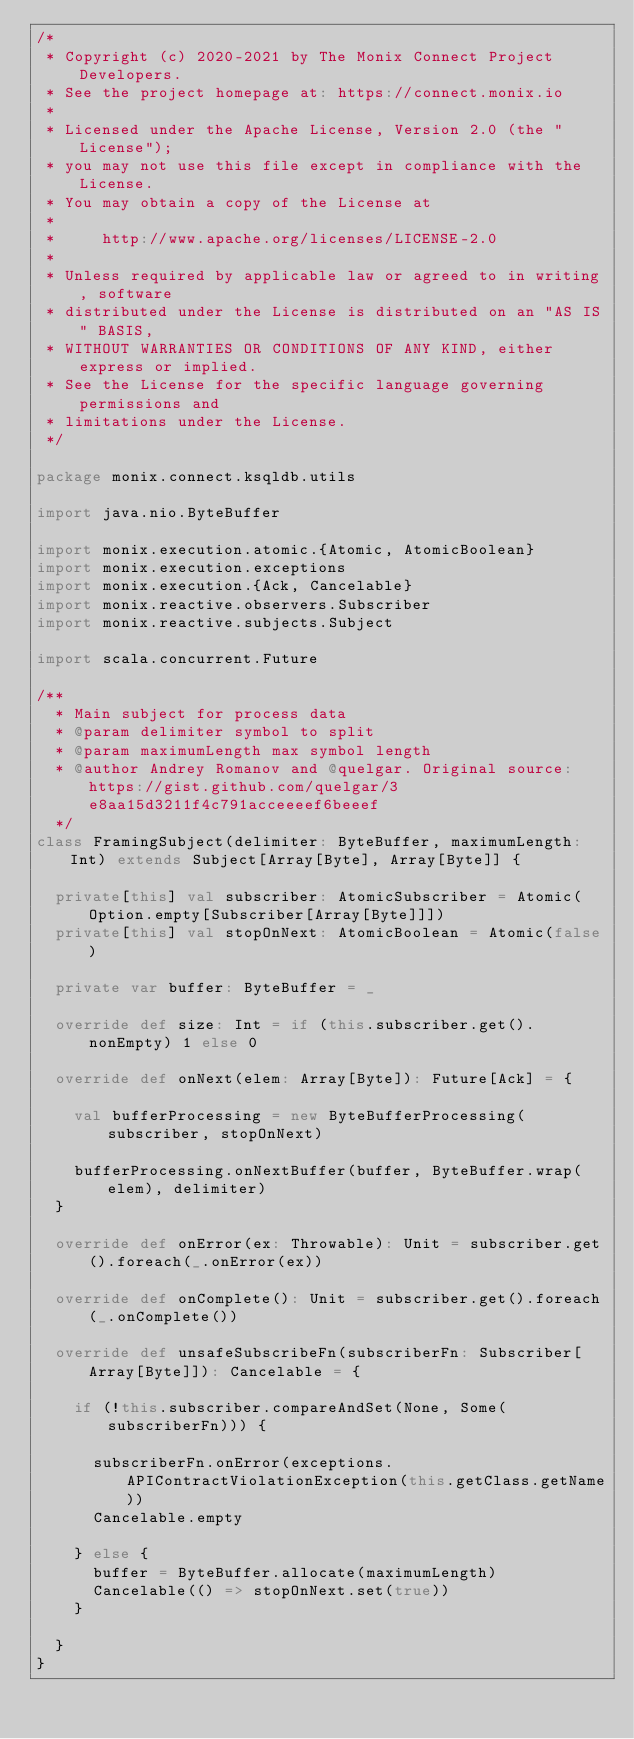Convert code to text. <code><loc_0><loc_0><loc_500><loc_500><_Scala_>/*
 * Copyright (c) 2020-2021 by The Monix Connect Project Developers.
 * See the project homepage at: https://connect.monix.io
 *
 * Licensed under the Apache License, Version 2.0 (the "License");
 * you may not use this file except in compliance with the License.
 * You may obtain a copy of the License at
 *
 *     http://www.apache.org/licenses/LICENSE-2.0
 *
 * Unless required by applicable law or agreed to in writing, software
 * distributed under the License is distributed on an "AS IS" BASIS,
 * WITHOUT WARRANTIES OR CONDITIONS OF ANY KIND, either express or implied.
 * See the License for the specific language governing permissions and
 * limitations under the License.
 */

package monix.connect.ksqldb.utils

import java.nio.ByteBuffer

import monix.execution.atomic.{Atomic, AtomicBoolean}
import monix.execution.exceptions
import monix.execution.{Ack, Cancelable}
import monix.reactive.observers.Subscriber
import monix.reactive.subjects.Subject

import scala.concurrent.Future

/**
  * Main subject for process data
  * @param delimiter symbol to split
  * @param maximumLength max symbol length
  * @author Andrey Romanov and @quelgar. Original source: https://gist.github.com/quelgar/3e8aa15d3211f4c791acceeeef6beeef
  */
class FramingSubject(delimiter: ByteBuffer, maximumLength: Int) extends Subject[Array[Byte], Array[Byte]] {

  private[this] val subscriber: AtomicSubscriber = Atomic(Option.empty[Subscriber[Array[Byte]]])
  private[this] val stopOnNext: AtomicBoolean = Atomic(false)

  private var buffer: ByteBuffer = _

  override def size: Int = if (this.subscriber.get().nonEmpty) 1 else 0

  override def onNext(elem: Array[Byte]): Future[Ack] = {

    val bufferProcessing = new ByteBufferProcessing(subscriber, stopOnNext)

    bufferProcessing.onNextBuffer(buffer, ByteBuffer.wrap(elem), delimiter)
  }

  override def onError(ex: Throwable): Unit = subscriber.get().foreach(_.onError(ex))

  override def onComplete(): Unit = subscriber.get().foreach(_.onComplete())

  override def unsafeSubscribeFn(subscriberFn: Subscriber[Array[Byte]]): Cancelable = {

    if (!this.subscriber.compareAndSet(None, Some(subscriberFn))) {

      subscriberFn.onError(exceptions.APIContractViolationException(this.getClass.getName))
      Cancelable.empty

    } else {
      buffer = ByteBuffer.allocate(maximumLength)
      Cancelable(() => stopOnNext.set(true))
    }

  }
}
</code> 